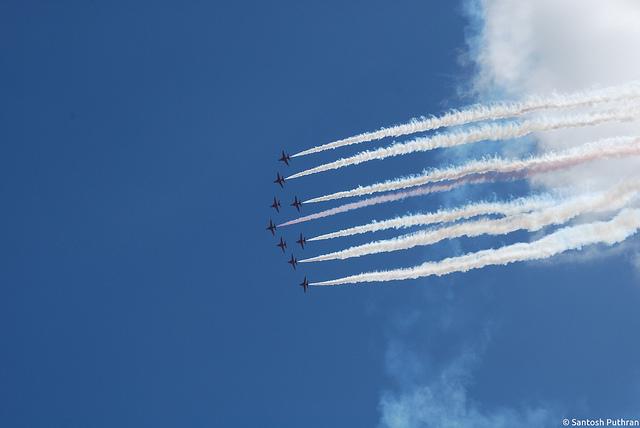What is the color of the sky?
Keep it brief. Blue. Is any of the smoke coming from the jets colored?
Be succinct. No. How many planes do you see?
Write a very short answer. 9. How many jets are flying?
Keep it brief. 9. 